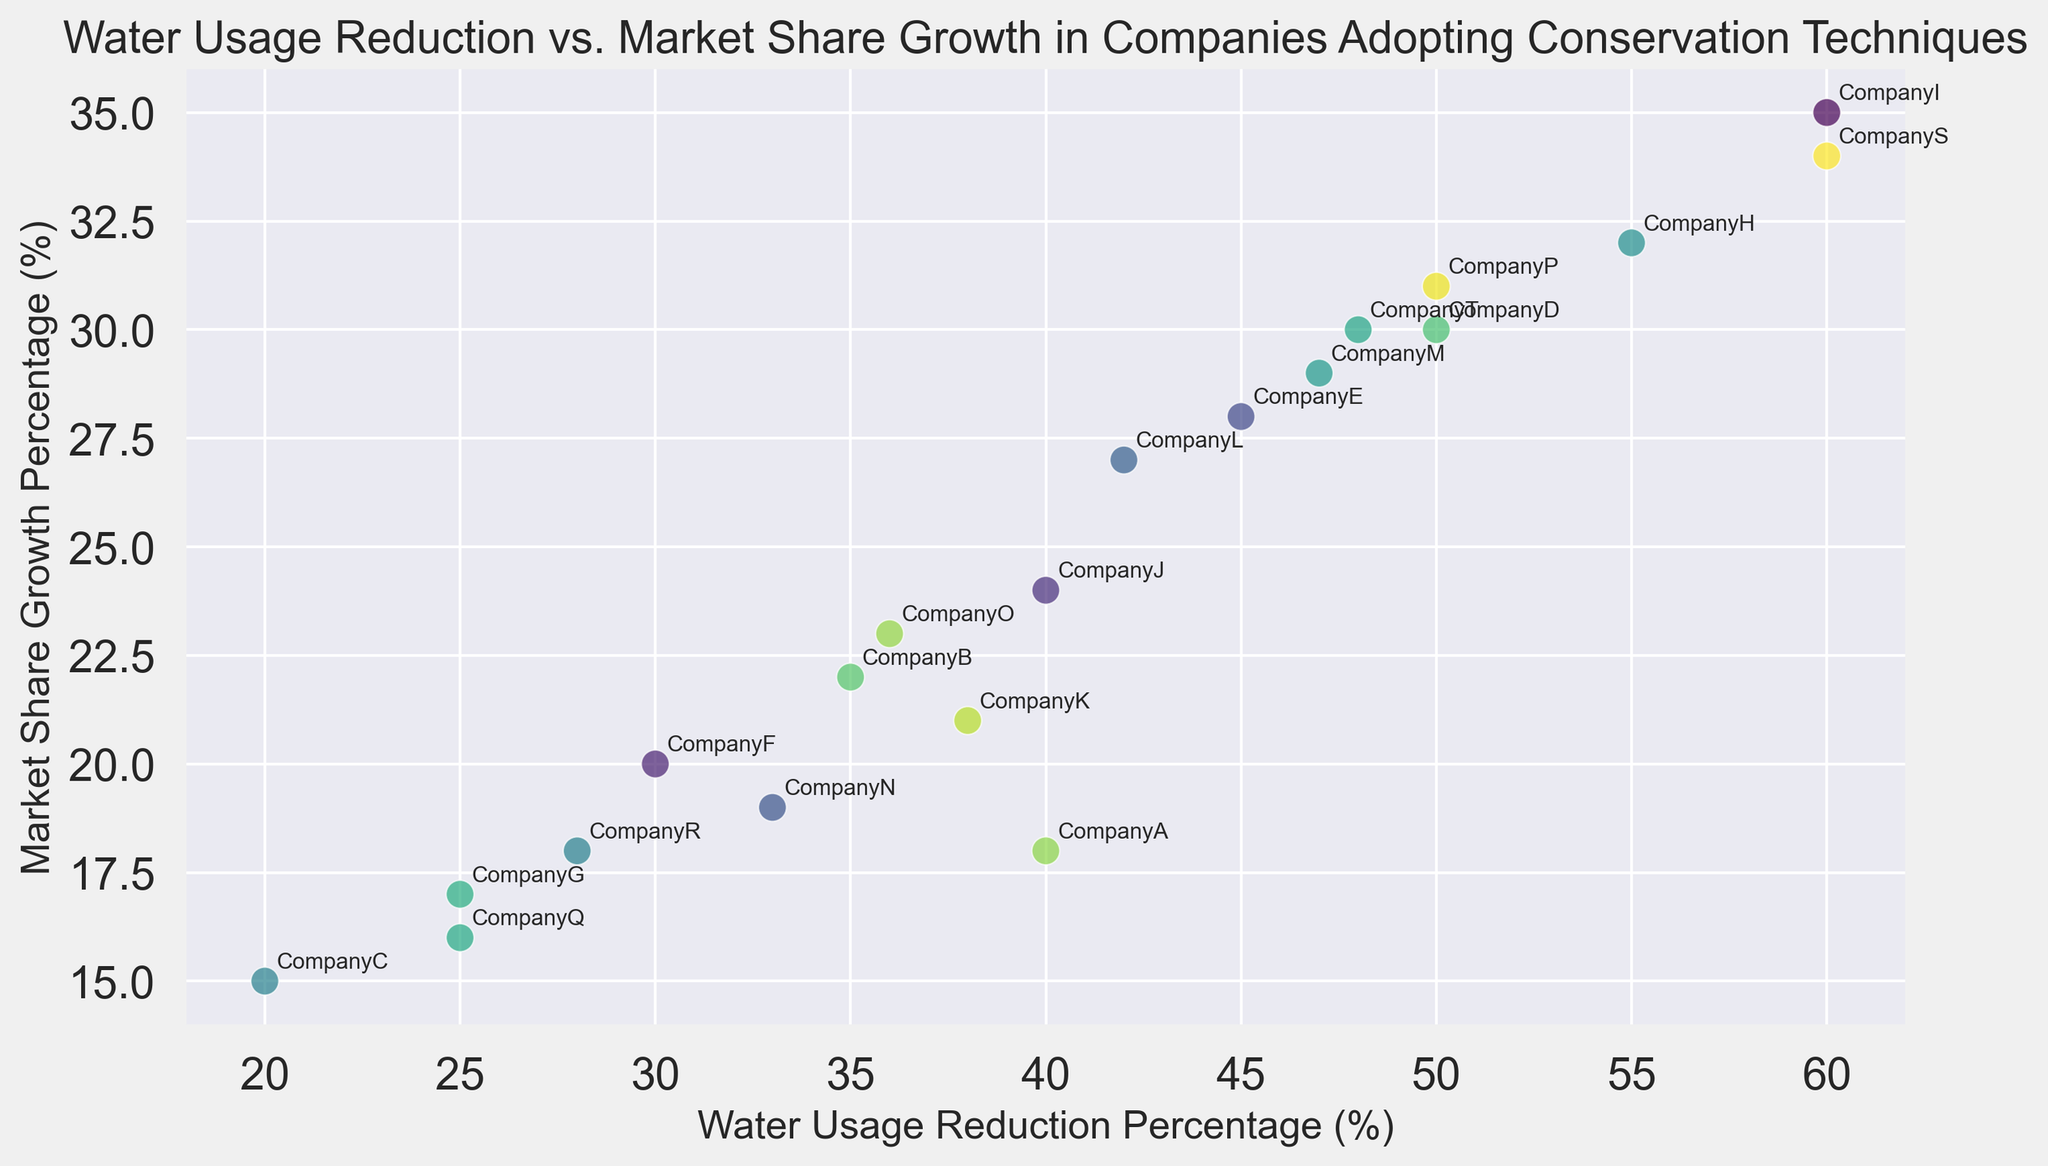What is the market share growth percentage for the company with the highest water usage reduction? Locate the company with the highest water usage reduction percentage (Company I and Company S with 60%) and check their market share growth percentage.
Answer: 35% for Company I and 34% for Company S Which company has the lowest market share growth percentage? Find the lowest market share growth percentage on the y-axis and identify the corresponding company, Company C with 15%.
Answer: Company C Between Company D and Company F, which has a higher percentage of water usage reduction? Compare the water usage reduction percentages of Company D (50%) and Company F (30%) from the x-axis values.
Answer: Company D What is the average market share growth percentage for companies with water usage reduction percentages above 50%? Identify companies (Company H, Company I, Company S, Company T) with water usage reduction above 50%. Their market share growth percentages are 32%, 35%, 34%, and 30% respectively. Average is (32 + 35 + 34 + 30) / 4
Answer: 32.75% Which companies have a market share growth percentage between 20% and 25%? Identify companies on the y-axis between 20% and 25% (Company B, Company J, Company K, Company O).
Answer: Company B, Company J, Company K, Company O What is the relationship between water usage reduction percentage and market share growth percentage? Observe the overall trend in scatter plot. Generally, as the water usage reduction percentage increases, the market share growth percentage also tends to increase.
Answer: Positive correlation Which company has a market share growth exactly at 22% and what is its water usage reduction percentage? Locate the data point at 22% Market Share Growth Percentage and find corresponding company (Company B), which has water usage reduction of 35%.
Answer: Company B, 35% How many companies have a water usage reduction percentage lower than 30%? Count the companies with water usage reduction percentages below 30% (Company C, Company G, Company Q, Company R).
Answer: 4 companies What is the total water usage reduction percentage for companies with a market share growth percentage of 30% or higher? Identify companies (Company D, Company H, Company I, Company M, Company P, Company S, Company T) whose market share growth percentage is 30% or higher. Summing their water usage reduction 50% + 55% + 60% + 47% + 50% + 60% + 48%
Answer: 370% Which company lies closest to the mid-point line of the scatter plot (intersection of x and y axes at their mid values)? Calculate midpoint of x and y axes (approximately 40% and 24%). Find the company closest to this point (Company T at 48%, 30%).
Answer: Company T 